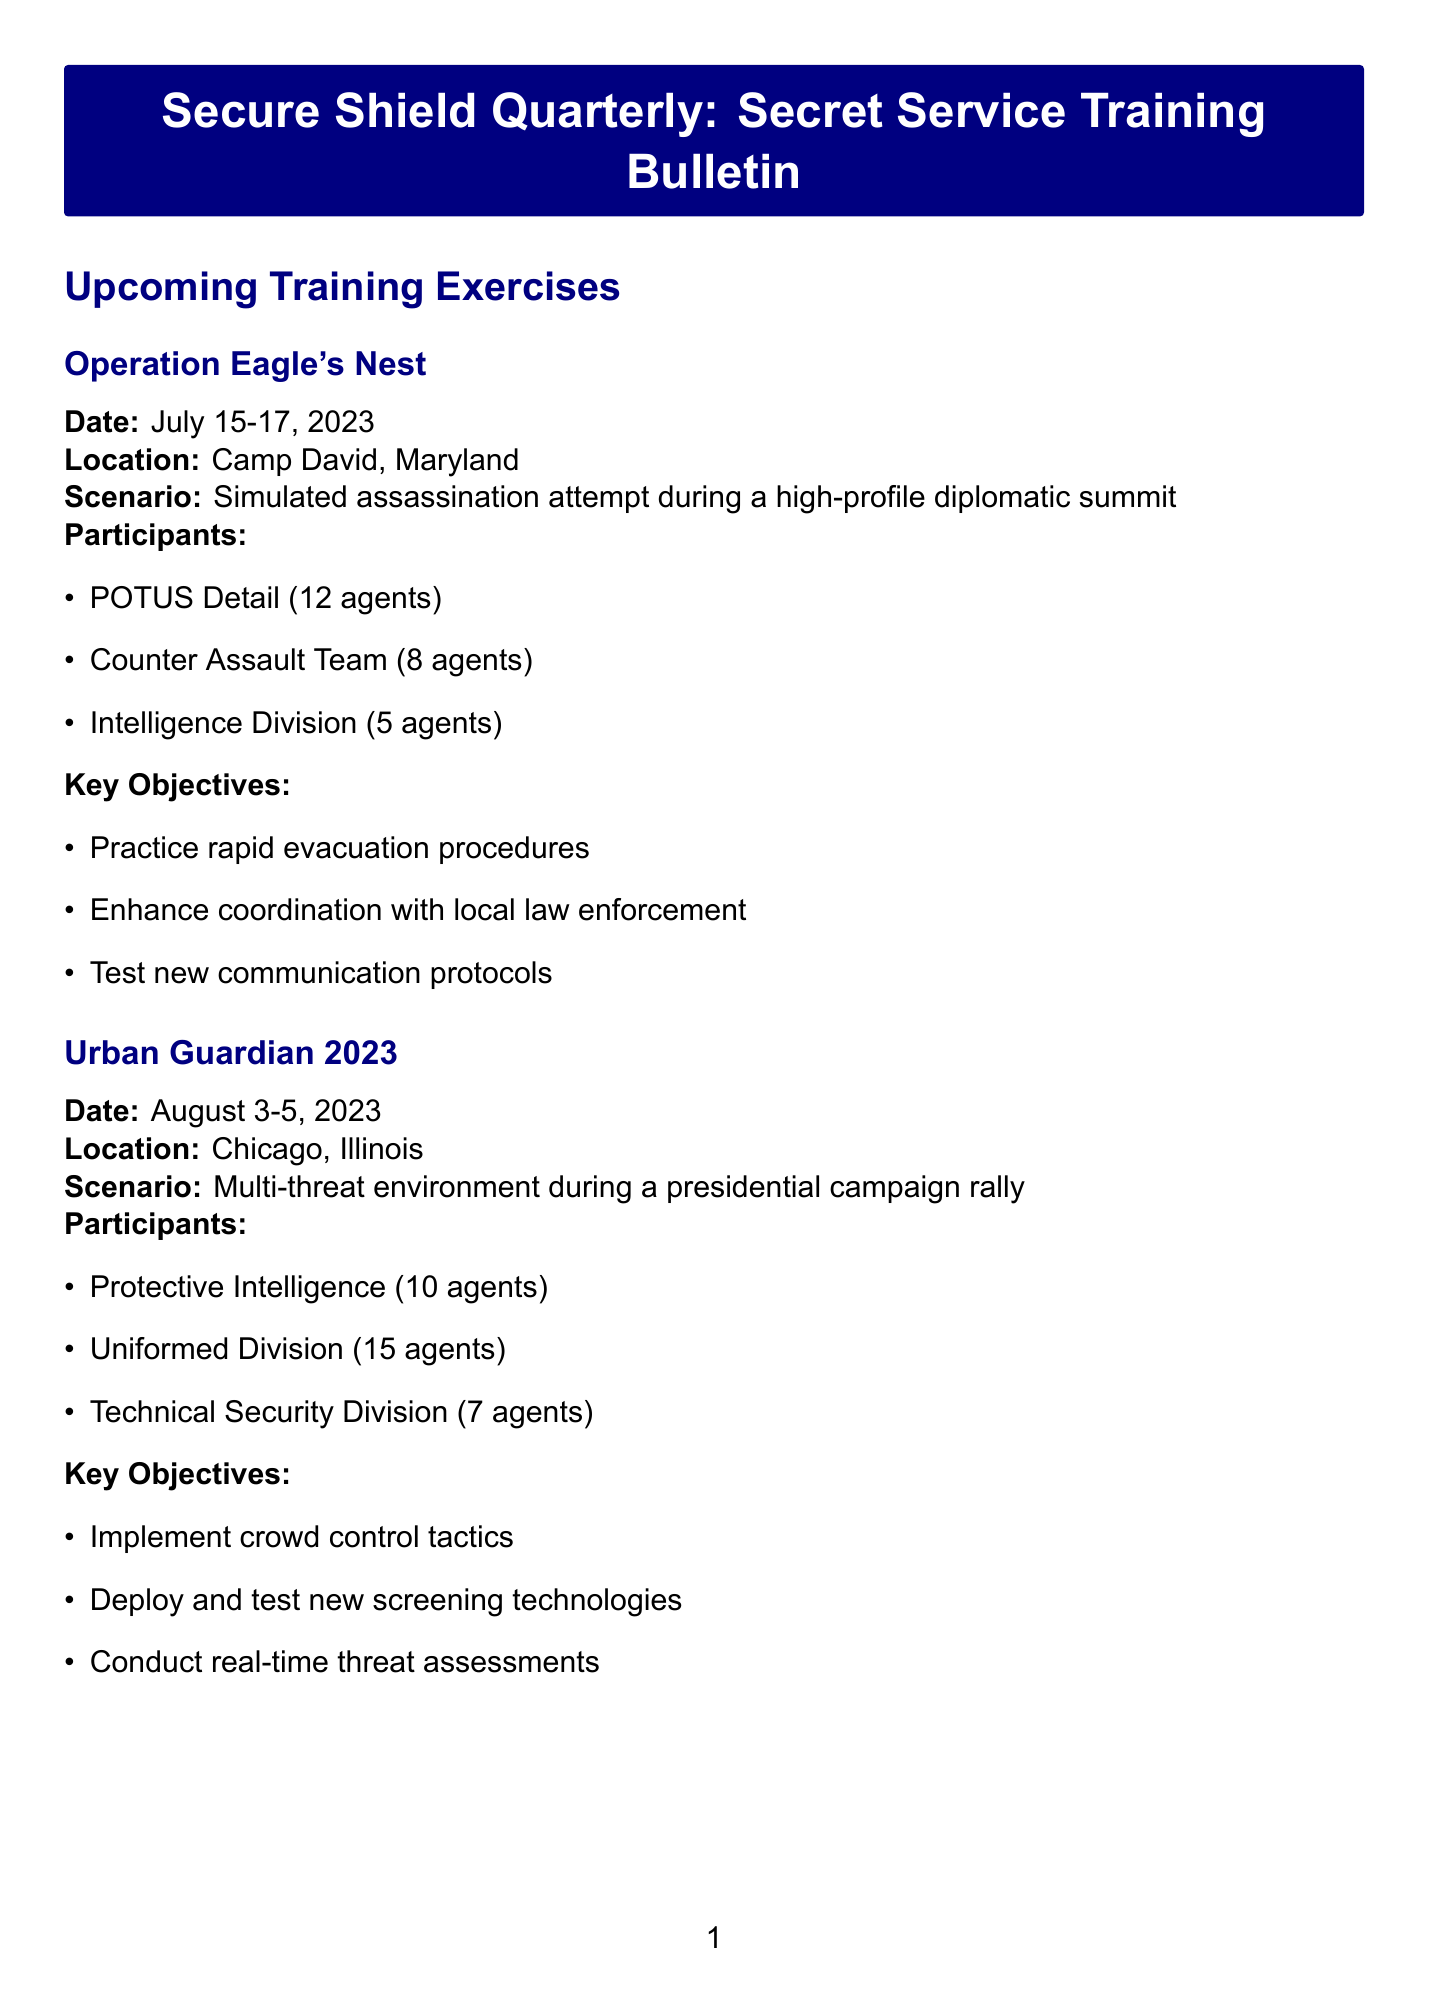What is the date of Operation Eagle's Nest? The date for Operation Eagle's Nest is directly provided in the document.
Answer: July 15-17, 2023 How many agents are assigned to the Counter Assault Team? The number of assigned agents for the Counter Assault Team can be found in the participants section of the exercise.
Answer: 8 agents What is the location of Urban Guardian 2023? The location for Urban Guardian 2023 is mentioned in the details of the training exercise.
Answer: Chicago, Illinois What is one of the key objectives of the Cyber Sentinel Initiative? Key objectives are listed for the Cyber Sentinel Initiative, and any one of them can be identified as an answer.
Answer: Identify and mitigate network vulnerabilities Which agency will participate in the International Cooperation Seminar? The International Cooperation Seminar mentions the agencies involved in the joint training session.
Answer: MI5 and Mossad How many agents are assigned to the Protective Intelligence role in Urban Guardian 2023? The number of agents in the Protective Intelligence role is provided in the document under the participants of the exercise.
Answer: 10 agents 